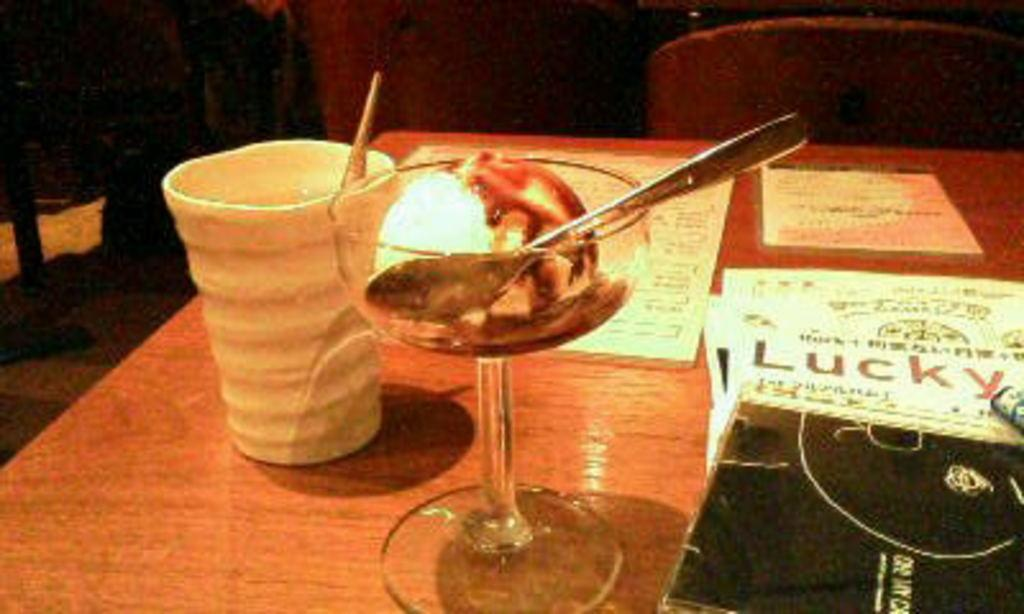What type of furniture is visible in the image? There are tables and chairs in the image. What is being served in the image? There is at least one ice cream cup and one glass in the image. What else can be seen on the tables? There are papers in the image. Can you describe the setting in the background? There are other tables and chairs in the background of the image. What type of act is being performed on the table in the image? There is no act being performed on the table in the image. Can you describe the jumping motion of the chairs in the image? The chairs in the image are stationary and not performing any jumping motion; they are simply tables and chairs in the image. 